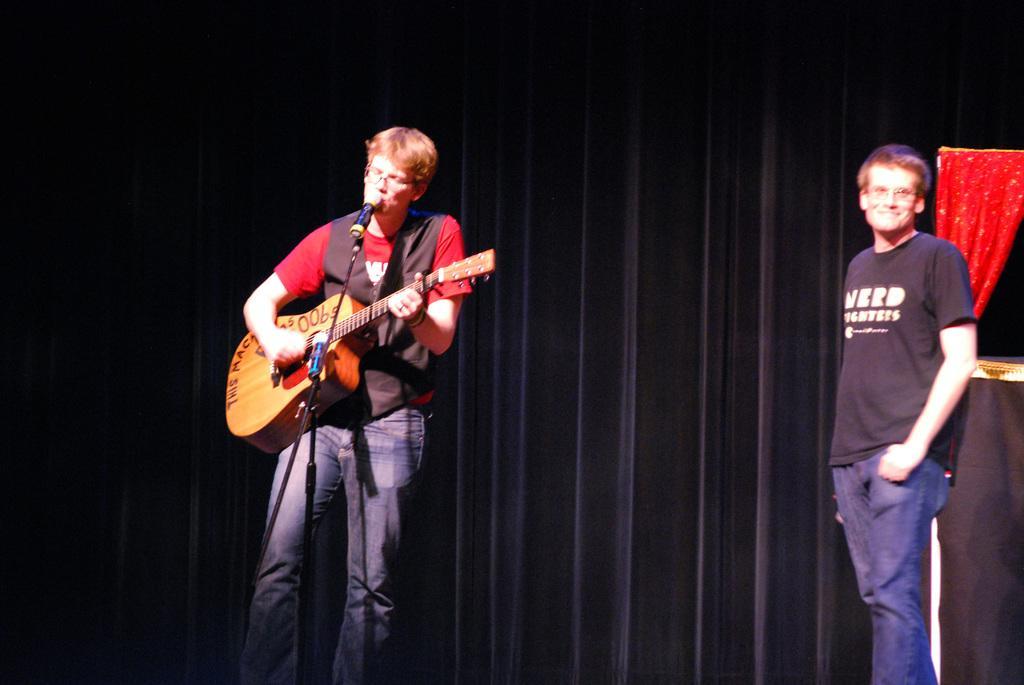How would you summarize this image in a sentence or two? In this picture we can see a man who is playing a guitar and he is singing on the mike. On the right side of the picture we can see a person who is standing on the floor. And he is in black color t shirt. On the background there is a curtain. 